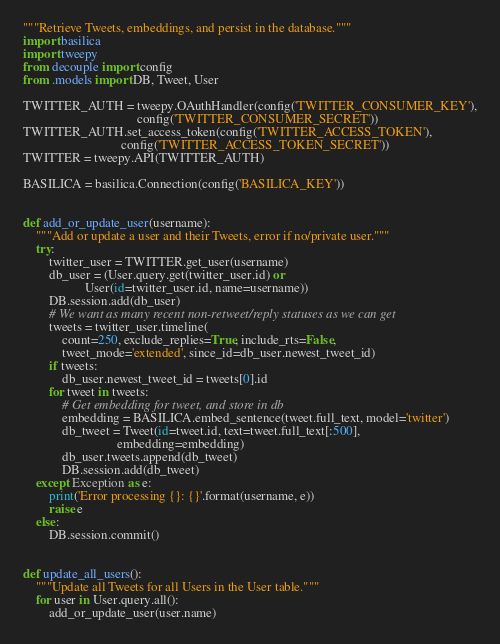<code> <loc_0><loc_0><loc_500><loc_500><_Python_>"""Retrieve Tweets, embeddings, and persist in the database."""
import basilica
import tweepy
from decouple import config
from .models import DB, Tweet, User

TWITTER_AUTH = tweepy.OAuthHandler(config('TWITTER_CONSUMER_KEY'),
                                   config('TWITTER_CONSUMER_SECRET'))
TWITTER_AUTH.set_access_token(config('TWITTER_ACCESS_TOKEN'),
                              config('TWITTER_ACCESS_TOKEN_SECRET'))
TWITTER = tweepy.API(TWITTER_AUTH)

BASILICA = basilica.Connection(config('BASILICA_KEY'))


def add_or_update_user(username):
    """Add or update a user and their Tweets, error if no/private user."""
    try:
        twitter_user = TWITTER.get_user(username)
        db_user = (User.query.get(twitter_user.id) or
                   User(id=twitter_user.id, name=username))
        DB.session.add(db_user)
        # We want as many recent non-retweet/reply statuses as we can get
        tweets = twitter_user.timeline(
            count=250, exclude_replies=True, include_rts=False,
            tweet_mode='extended', since_id=db_user.newest_tweet_id)
        if tweets:
            db_user.newest_tweet_id = tweets[0].id
        for tweet in tweets:
            # Get embedding for tweet, and store in db
            embedding = BASILICA.embed_sentence(tweet.full_text, model='twitter')
            db_tweet = Tweet(id=tweet.id, text=tweet.full_text[:500],
                             embedding=embedding)
            db_user.tweets.append(db_tweet)
            DB.session.add(db_tweet)
    except Exception as e:
        print('Error processing {}: {}'.format(username, e))
        raise e
    else:
        DB.session.commit()


def update_all_users():
    """Update all Tweets for all Users in the User table."""
    for user in User.query.all():
        add_or_update_user(user.name)
</code> 